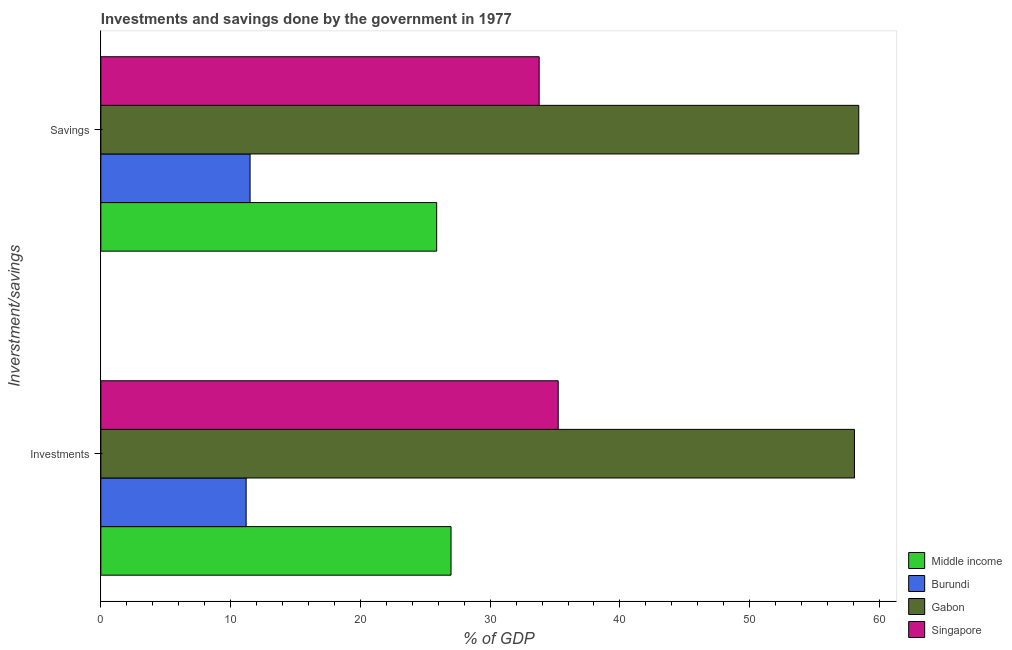How many groups of bars are there?
Keep it short and to the point. 2. Are the number of bars per tick equal to the number of legend labels?
Make the answer very short. Yes. What is the label of the 2nd group of bars from the top?
Ensure brevity in your answer.  Investments. What is the investments of government in Gabon?
Your response must be concise. 58.07. Across all countries, what is the maximum investments of government?
Offer a very short reply. 58.07. Across all countries, what is the minimum savings of government?
Keep it short and to the point. 11.5. In which country was the investments of government maximum?
Your answer should be very brief. Gabon. In which country was the savings of government minimum?
Give a very brief answer. Burundi. What is the total investments of government in the graph?
Your answer should be very brief. 131.49. What is the difference between the investments of government in Burundi and that in Singapore?
Your answer should be compact. -24.05. What is the difference between the savings of government in Middle income and the investments of government in Singapore?
Your response must be concise. -9.36. What is the average investments of government per country?
Your response must be concise. 32.87. What is the difference between the investments of government and savings of government in Gabon?
Your answer should be compact. -0.33. What is the ratio of the investments of government in Singapore to that in Middle income?
Your response must be concise. 1.31. Is the investments of government in Middle income less than that in Singapore?
Provide a succinct answer. Yes. What does the 3rd bar from the top in Savings represents?
Provide a succinct answer. Burundi. What does the 2nd bar from the bottom in Savings represents?
Your answer should be compact. Burundi. How many bars are there?
Offer a terse response. 8. How many countries are there in the graph?
Give a very brief answer. 4. What is the difference between two consecutive major ticks on the X-axis?
Ensure brevity in your answer.  10. Are the values on the major ticks of X-axis written in scientific E-notation?
Offer a very short reply. No. Does the graph contain grids?
Keep it short and to the point. No. How many legend labels are there?
Your answer should be very brief. 4. What is the title of the graph?
Make the answer very short. Investments and savings done by the government in 1977. Does "South Asia" appear as one of the legend labels in the graph?
Your response must be concise. No. What is the label or title of the X-axis?
Provide a succinct answer. % of GDP. What is the label or title of the Y-axis?
Your response must be concise. Inverstment/savings. What is the % of GDP in Middle income in Investments?
Provide a succinct answer. 26.98. What is the % of GDP of Burundi in Investments?
Your answer should be compact. 11.2. What is the % of GDP in Gabon in Investments?
Your response must be concise. 58.07. What is the % of GDP in Singapore in Investments?
Your answer should be compact. 35.24. What is the % of GDP in Middle income in Savings?
Your answer should be compact. 25.88. What is the % of GDP of Burundi in Savings?
Offer a terse response. 11.5. What is the % of GDP of Gabon in Savings?
Your response must be concise. 58.4. What is the % of GDP in Singapore in Savings?
Provide a succinct answer. 33.78. Across all Inverstment/savings, what is the maximum % of GDP of Middle income?
Your response must be concise. 26.98. Across all Inverstment/savings, what is the maximum % of GDP in Burundi?
Your answer should be compact. 11.5. Across all Inverstment/savings, what is the maximum % of GDP in Gabon?
Provide a short and direct response. 58.4. Across all Inverstment/savings, what is the maximum % of GDP in Singapore?
Ensure brevity in your answer.  35.24. Across all Inverstment/savings, what is the minimum % of GDP of Middle income?
Give a very brief answer. 25.88. Across all Inverstment/savings, what is the minimum % of GDP of Burundi?
Your answer should be compact. 11.2. Across all Inverstment/savings, what is the minimum % of GDP of Gabon?
Offer a very short reply. 58.07. Across all Inverstment/savings, what is the minimum % of GDP of Singapore?
Offer a terse response. 33.78. What is the total % of GDP of Middle income in the graph?
Offer a terse response. 52.86. What is the total % of GDP in Burundi in the graph?
Provide a short and direct response. 22.7. What is the total % of GDP of Gabon in the graph?
Ensure brevity in your answer.  116.47. What is the total % of GDP in Singapore in the graph?
Provide a succinct answer. 69.02. What is the difference between the % of GDP of Middle income in Investments and that in Savings?
Ensure brevity in your answer.  1.11. What is the difference between the % of GDP in Burundi in Investments and that in Savings?
Your response must be concise. -0.3. What is the difference between the % of GDP in Gabon in Investments and that in Savings?
Your answer should be very brief. -0.33. What is the difference between the % of GDP in Singapore in Investments and that in Savings?
Your response must be concise. 1.47. What is the difference between the % of GDP in Middle income in Investments and the % of GDP in Burundi in Savings?
Offer a terse response. 15.48. What is the difference between the % of GDP of Middle income in Investments and the % of GDP of Gabon in Savings?
Give a very brief answer. -31.42. What is the difference between the % of GDP in Middle income in Investments and the % of GDP in Singapore in Savings?
Offer a terse response. -6.79. What is the difference between the % of GDP of Burundi in Investments and the % of GDP of Gabon in Savings?
Keep it short and to the point. -47.21. What is the difference between the % of GDP of Burundi in Investments and the % of GDP of Singapore in Savings?
Make the answer very short. -22.58. What is the difference between the % of GDP in Gabon in Investments and the % of GDP in Singapore in Savings?
Offer a terse response. 24.29. What is the average % of GDP of Middle income per Inverstment/savings?
Keep it short and to the point. 26.43. What is the average % of GDP in Burundi per Inverstment/savings?
Offer a terse response. 11.35. What is the average % of GDP of Gabon per Inverstment/savings?
Your response must be concise. 58.24. What is the average % of GDP in Singapore per Inverstment/savings?
Keep it short and to the point. 34.51. What is the difference between the % of GDP of Middle income and % of GDP of Burundi in Investments?
Your answer should be very brief. 15.79. What is the difference between the % of GDP of Middle income and % of GDP of Gabon in Investments?
Give a very brief answer. -31.09. What is the difference between the % of GDP in Middle income and % of GDP in Singapore in Investments?
Make the answer very short. -8.26. What is the difference between the % of GDP of Burundi and % of GDP of Gabon in Investments?
Offer a very short reply. -46.87. What is the difference between the % of GDP of Burundi and % of GDP of Singapore in Investments?
Your answer should be very brief. -24.05. What is the difference between the % of GDP of Gabon and % of GDP of Singapore in Investments?
Give a very brief answer. 22.83. What is the difference between the % of GDP in Middle income and % of GDP in Burundi in Savings?
Ensure brevity in your answer.  14.38. What is the difference between the % of GDP of Middle income and % of GDP of Gabon in Savings?
Make the answer very short. -32.52. What is the difference between the % of GDP of Middle income and % of GDP of Singapore in Savings?
Make the answer very short. -7.9. What is the difference between the % of GDP of Burundi and % of GDP of Gabon in Savings?
Provide a succinct answer. -46.9. What is the difference between the % of GDP of Burundi and % of GDP of Singapore in Savings?
Keep it short and to the point. -22.28. What is the difference between the % of GDP of Gabon and % of GDP of Singapore in Savings?
Make the answer very short. 24.63. What is the ratio of the % of GDP in Middle income in Investments to that in Savings?
Your response must be concise. 1.04. What is the ratio of the % of GDP in Burundi in Investments to that in Savings?
Offer a very short reply. 0.97. What is the ratio of the % of GDP of Gabon in Investments to that in Savings?
Provide a succinct answer. 0.99. What is the ratio of the % of GDP in Singapore in Investments to that in Savings?
Keep it short and to the point. 1.04. What is the difference between the highest and the second highest % of GDP in Middle income?
Give a very brief answer. 1.11. What is the difference between the highest and the second highest % of GDP of Burundi?
Keep it short and to the point. 0.3. What is the difference between the highest and the second highest % of GDP of Gabon?
Your answer should be compact. 0.33. What is the difference between the highest and the second highest % of GDP in Singapore?
Your answer should be compact. 1.47. What is the difference between the highest and the lowest % of GDP in Middle income?
Your response must be concise. 1.11. What is the difference between the highest and the lowest % of GDP in Burundi?
Give a very brief answer. 0.3. What is the difference between the highest and the lowest % of GDP in Gabon?
Offer a very short reply. 0.33. What is the difference between the highest and the lowest % of GDP of Singapore?
Keep it short and to the point. 1.47. 